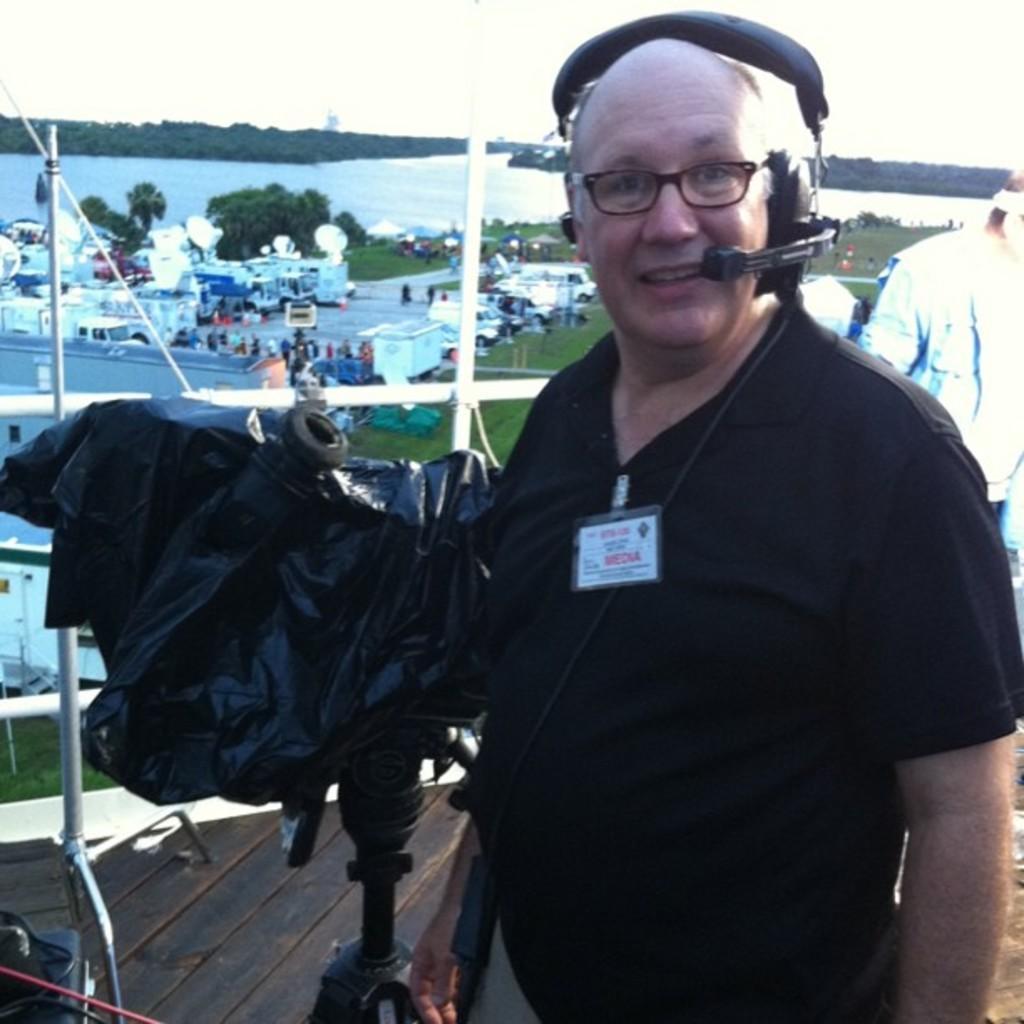Could you give a brief overview of what you see in this image? In this image I can see the person is standing and wearing black color dress. Back I can see few vehicles, few people, trees, water and the sky. In front I can see the stand, black color cover and few objects on the wooden floor. 